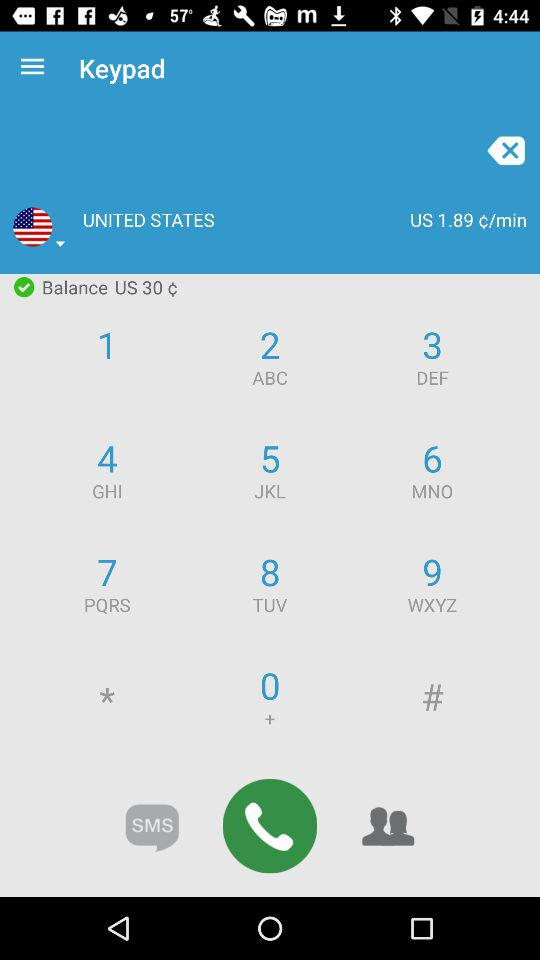What is the balance? The balance is "US 30 ¢". 